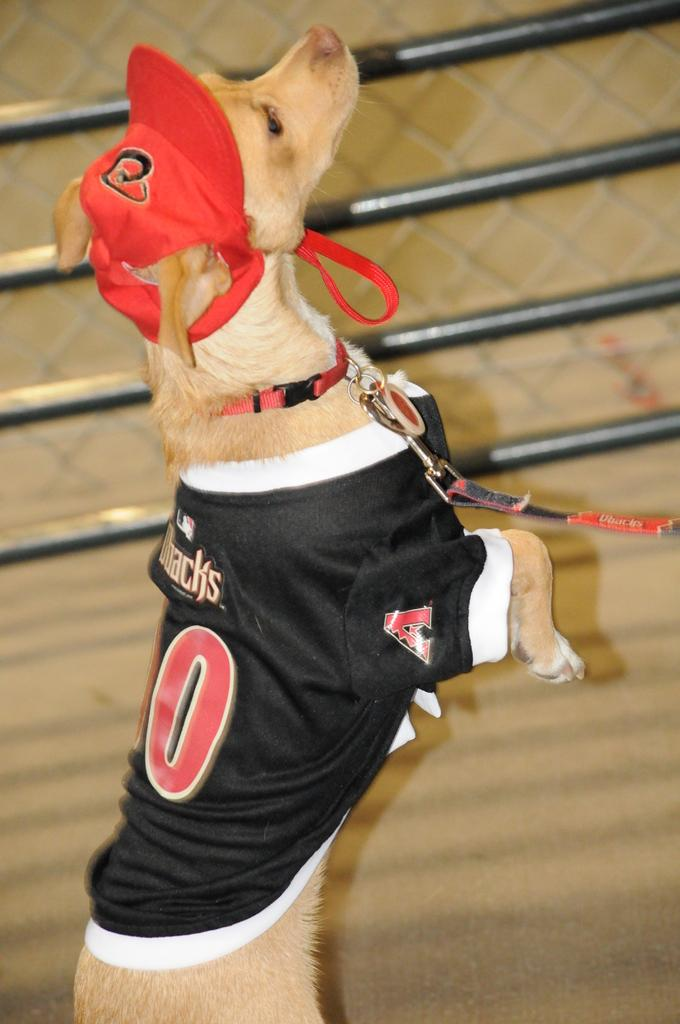<image>
Create a compact narrative representing the image presented. the dog is wearing a jersey with letter A on the sleeve 